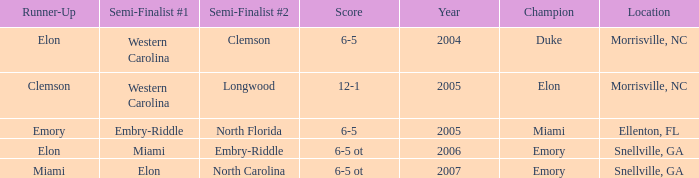When Embry-Riddle made it to the first semi finalist slot, list all the runners up. Emory. Would you mind parsing the complete table? {'header': ['Runner-Up', 'Semi-Finalist #1', 'Semi-Finalist #2', 'Score', 'Year', 'Champion', 'Location'], 'rows': [['Elon', 'Western Carolina', 'Clemson', '6-5', '2004', 'Duke', 'Morrisville, NC'], ['Clemson', 'Western Carolina', 'Longwood', '12-1', '2005', 'Elon', 'Morrisville, NC'], ['Emory', 'Embry-Riddle', 'North Florida', '6-5', '2005', 'Miami', 'Ellenton, FL'], ['Elon', 'Miami', 'Embry-Riddle', '6-5 ot', '2006', 'Emory', 'Snellville, GA'], ['Miami', 'Elon', 'North Carolina', '6-5 ot', '2007', 'Emory', 'Snellville, GA']]} 